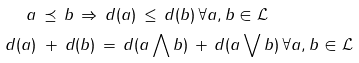<formula> <loc_0><loc_0><loc_500><loc_500>a \, & \preceq \, b \, \Rightarrow \, d ( a ) \, \leq \, d ( b ) \, \forall a , b \in { \mathcal { L } } \\ d ( a ) \, & \, + \, d ( b ) \, = \, d ( a \bigwedge b ) \, + \, d ( a \bigvee b ) \, \forall a , b \in { \mathcal { L } }</formula> 